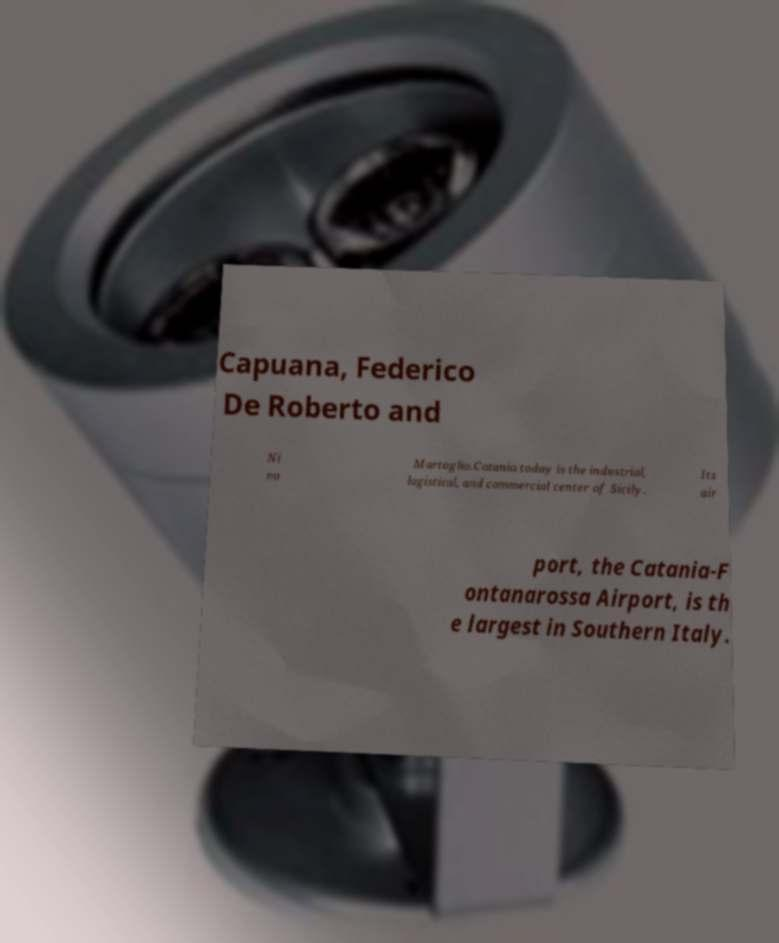Please read and relay the text visible in this image. What does it say? Capuana, Federico De Roberto and Ni no Martoglio.Catania today is the industrial, logistical, and commercial center of Sicily. Its air port, the Catania-F ontanarossa Airport, is th e largest in Southern Italy. 